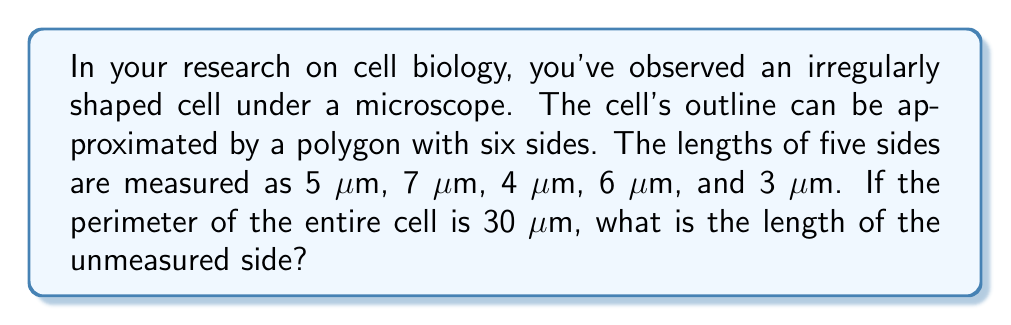Teach me how to tackle this problem. To solve this problem, we'll follow these steps:

1. Let's define the unknown side length as $x$ μm.

2. We know that the perimeter of a polygon is the sum of all its side lengths. In this case, we have:

   $$5 + 7 + 4 + 6 + 3 + x = 30$$

3. Now, let's solve for $x$:
   
   $$25 + x = 30$$
   $$x = 30 - 25$$
   $$x = 5$$

4. Therefore, the length of the unmeasured side is 5 μm.

5. We can verify this by adding all sides:
   
   $$5 + 7 + 4 + 6 + 3 + 5 = 30$$

   which confirms our result.

[asy]
unitsize(10mm);
path p = (0,0)--(2,1)--(3,3)--(1,4)--(-1,3)--(-2,1)--cycle;
draw(p);
label("5 μm", (1,0.5), S);
label("7 μm", (2.5,2), E);
label("4 μm", (2,3.5), N);
label("6 μm", (0,3.5), N);
label("3 μm", (-1.5,2), W);
label("x μm", (-1,0.5), S);
[/asy]
Answer: 5 μm 